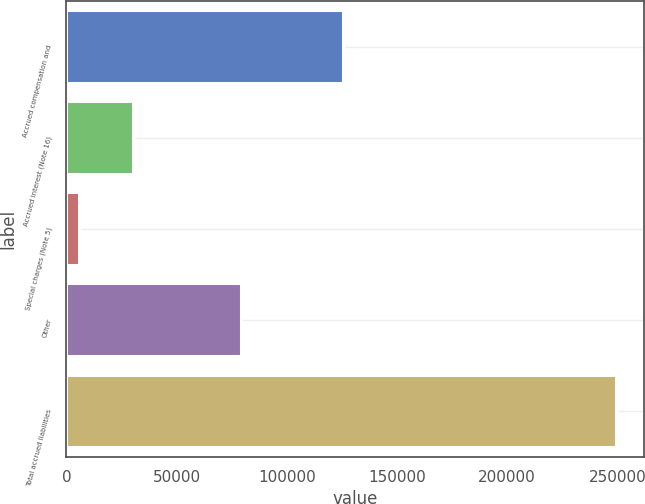Convert chart. <chart><loc_0><loc_0><loc_500><loc_500><bar_chart><fcel>Accrued compensation and<fcel>Accrued interest (Note 16)<fcel>Special charges (Note 5)<fcel>Other<fcel>Total accrued liabilities<nl><fcel>125500<fcel>30248.8<fcel>5877<fcel>79412<fcel>249595<nl></chart> 